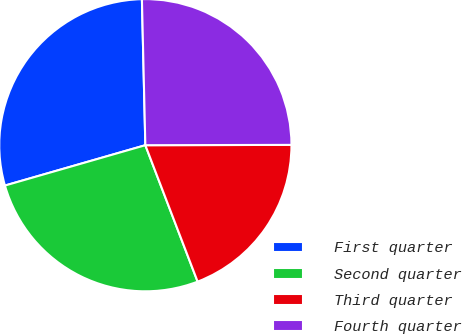<chart> <loc_0><loc_0><loc_500><loc_500><pie_chart><fcel>First quarter<fcel>Second quarter<fcel>Third quarter<fcel>Fourth quarter<nl><fcel>29.08%<fcel>26.37%<fcel>19.21%<fcel>25.34%<nl></chart> 